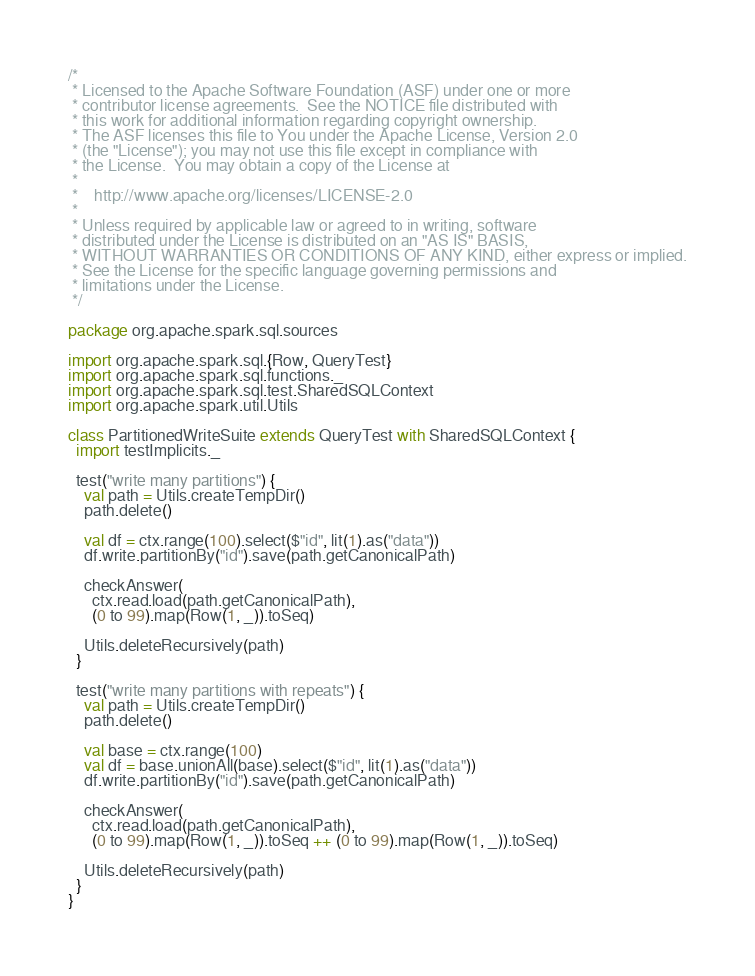<code> <loc_0><loc_0><loc_500><loc_500><_Scala_>/*
 * Licensed to the Apache Software Foundation (ASF) under one or more
 * contributor license agreements.  See the NOTICE file distributed with
 * this work for additional information regarding copyright ownership.
 * The ASF licenses this file to You under the Apache License, Version 2.0
 * (the "License"); you may not use this file except in compliance with
 * the License.  You may obtain a copy of the License at
 *
 *    http://www.apache.org/licenses/LICENSE-2.0
 *
 * Unless required by applicable law or agreed to in writing, software
 * distributed under the License is distributed on an "AS IS" BASIS,
 * WITHOUT WARRANTIES OR CONDITIONS OF ANY KIND, either express or implied.
 * See the License for the specific language governing permissions and
 * limitations under the License.
 */

package org.apache.spark.sql.sources

import org.apache.spark.sql.{Row, QueryTest}
import org.apache.spark.sql.functions._
import org.apache.spark.sql.test.SharedSQLContext
import org.apache.spark.util.Utils

class PartitionedWriteSuite extends QueryTest with SharedSQLContext {
  import testImplicits._

  test("write many partitions") {
    val path = Utils.createTempDir()
    path.delete()

    val df = ctx.range(100).select($"id", lit(1).as("data"))
    df.write.partitionBy("id").save(path.getCanonicalPath)

    checkAnswer(
      ctx.read.load(path.getCanonicalPath),
      (0 to 99).map(Row(1, _)).toSeq)

    Utils.deleteRecursively(path)
  }

  test("write many partitions with repeats") {
    val path = Utils.createTempDir()
    path.delete()

    val base = ctx.range(100)
    val df = base.unionAll(base).select($"id", lit(1).as("data"))
    df.write.partitionBy("id").save(path.getCanonicalPath)

    checkAnswer(
      ctx.read.load(path.getCanonicalPath),
      (0 to 99).map(Row(1, _)).toSeq ++ (0 to 99).map(Row(1, _)).toSeq)

    Utils.deleteRecursively(path)
  }
}
</code> 